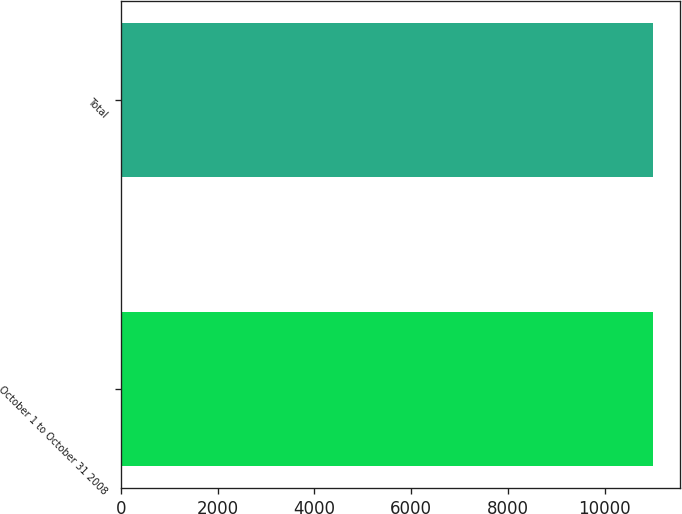Convert chart to OTSL. <chart><loc_0><loc_0><loc_500><loc_500><bar_chart><fcel>October 1 to October 31 2008<fcel>Total<nl><fcel>11000<fcel>11000.1<nl></chart> 